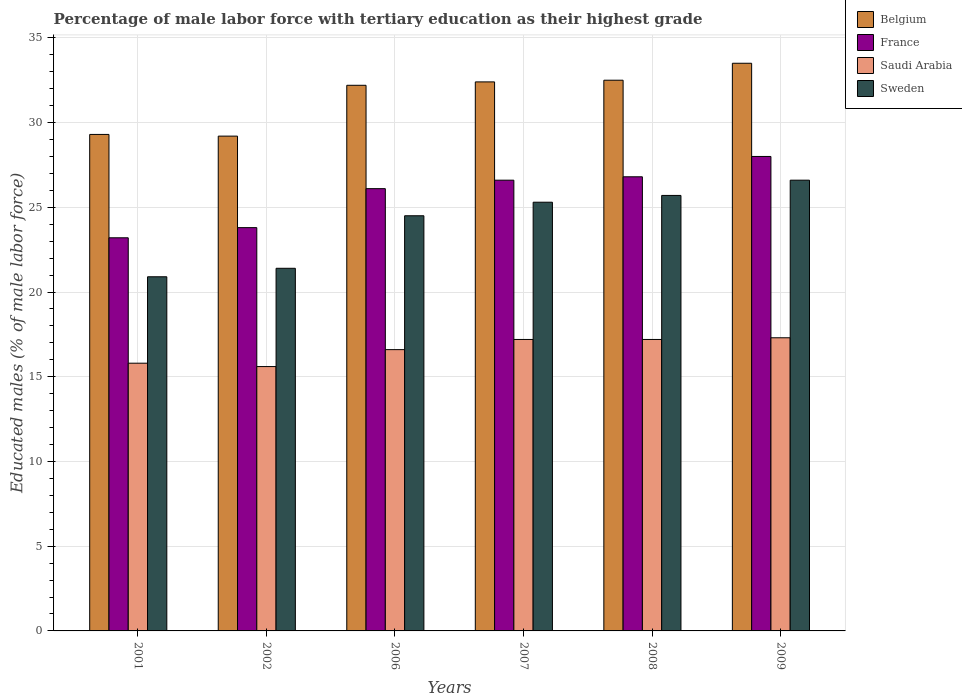How many different coloured bars are there?
Provide a short and direct response. 4. How many groups of bars are there?
Ensure brevity in your answer.  6. Are the number of bars on each tick of the X-axis equal?
Ensure brevity in your answer.  Yes. How many bars are there on the 4th tick from the left?
Make the answer very short. 4. In how many cases, is the number of bars for a given year not equal to the number of legend labels?
Give a very brief answer. 0. What is the percentage of male labor force with tertiary education in Sweden in 2008?
Keep it short and to the point. 25.7. Across all years, what is the maximum percentage of male labor force with tertiary education in Saudi Arabia?
Offer a terse response. 17.3. Across all years, what is the minimum percentage of male labor force with tertiary education in Sweden?
Your answer should be compact. 20.9. In which year was the percentage of male labor force with tertiary education in Sweden maximum?
Your answer should be very brief. 2009. In which year was the percentage of male labor force with tertiary education in Belgium minimum?
Your response must be concise. 2002. What is the total percentage of male labor force with tertiary education in Saudi Arabia in the graph?
Offer a very short reply. 99.7. What is the difference between the percentage of male labor force with tertiary education in Sweden in 2006 and that in 2009?
Make the answer very short. -2.1. What is the difference between the percentage of male labor force with tertiary education in Saudi Arabia in 2007 and the percentage of male labor force with tertiary education in Sweden in 2006?
Make the answer very short. -7.3. What is the average percentage of male labor force with tertiary education in Saudi Arabia per year?
Provide a succinct answer. 16.62. In the year 2009, what is the difference between the percentage of male labor force with tertiary education in France and percentage of male labor force with tertiary education in Sweden?
Offer a very short reply. 1.4. In how many years, is the percentage of male labor force with tertiary education in Saudi Arabia greater than 10 %?
Offer a terse response. 6. Is the percentage of male labor force with tertiary education in Sweden in 2002 less than that in 2008?
Your response must be concise. Yes. Is the difference between the percentage of male labor force with tertiary education in France in 2008 and 2009 greater than the difference between the percentage of male labor force with tertiary education in Sweden in 2008 and 2009?
Keep it short and to the point. No. What is the difference between the highest and the second highest percentage of male labor force with tertiary education in Saudi Arabia?
Provide a short and direct response. 0.1. What is the difference between the highest and the lowest percentage of male labor force with tertiary education in France?
Give a very brief answer. 4.8. What does the 3rd bar from the right in 2008 represents?
Make the answer very short. France. What is the difference between two consecutive major ticks on the Y-axis?
Provide a short and direct response. 5. Are the values on the major ticks of Y-axis written in scientific E-notation?
Make the answer very short. No. How are the legend labels stacked?
Your answer should be compact. Vertical. What is the title of the graph?
Make the answer very short. Percentage of male labor force with tertiary education as their highest grade. Does "Timor-Leste" appear as one of the legend labels in the graph?
Your response must be concise. No. What is the label or title of the X-axis?
Offer a terse response. Years. What is the label or title of the Y-axis?
Offer a terse response. Educated males (% of male labor force). What is the Educated males (% of male labor force) in Belgium in 2001?
Offer a very short reply. 29.3. What is the Educated males (% of male labor force) in France in 2001?
Provide a short and direct response. 23.2. What is the Educated males (% of male labor force) in Saudi Arabia in 2001?
Ensure brevity in your answer.  15.8. What is the Educated males (% of male labor force) of Sweden in 2001?
Offer a terse response. 20.9. What is the Educated males (% of male labor force) of Belgium in 2002?
Give a very brief answer. 29.2. What is the Educated males (% of male labor force) in France in 2002?
Keep it short and to the point. 23.8. What is the Educated males (% of male labor force) in Saudi Arabia in 2002?
Ensure brevity in your answer.  15.6. What is the Educated males (% of male labor force) in Sweden in 2002?
Make the answer very short. 21.4. What is the Educated males (% of male labor force) in Belgium in 2006?
Give a very brief answer. 32.2. What is the Educated males (% of male labor force) of France in 2006?
Ensure brevity in your answer.  26.1. What is the Educated males (% of male labor force) of Saudi Arabia in 2006?
Your response must be concise. 16.6. What is the Educated males (% of male labor force) in Sweden in 2006?
Your answer should be compact. 24.5. What is the Educated males (% of male labor force) of Belgium in 2007?
Offer a terse response. 32.4. What is the Educated males (% of male labor force) in France in 2007?
Your answer should be compact. 26.6. What is the Educated males (% of male labor force) of Saudi Arabia in 2007?
Provide a short and direct response. 17.2. What is the Educated males (% of male labor force) of Sweden in 2007?
Keep it short and to the point. 25.3. What is the Educated males (% of male labor force) of Belgium in 2008?
Ensure brevity in your answer.  32.5. What is the Educated males (% of male labor force) in France in 2008?
Ensure brevity in your answer.  26.8. What is the Educated males (% of male labor force) of Saudi Arabia in 2008?
Provide a short and direct response. 17.2. What is the Educated males (% of male labor force) in Sweden in 2008?
Make the answer very short. 25.7. What is the Educated males (% of male labor force) of Belgium in 2009?
Make the answer very short. 33.5. What is the Educated males (% of male labor force) in France in 2009?
Offer a terse response. 28. What is the Educated males (% of male labor force) in Saudi Arabia in 2009?
Provide a succinct answer. 17.3. What is the Educated males (% of male labor force) in Sweden in 2009?
Your response must be concise. 26.6. Across all years, what is the maximum Educated males (% of male labor force) of Belgium?
Ensure brevity in your answer.  33.5. Across all years, what is the maximum Educated males (% of male labor force) in France?
Provide a succinct answer. 28. Across all years, what is the maximum Educated males (% of male labor force) in Saudi Arabia?
Make the answer very short. 17.3. Across all years, what is the maximum Educated males (% of male labor force) of Sweden?
Provide a succinct answer. 26.6. Across all years, what is the minimum Educated males (% of male labor force) of Belgium?
Keep it short and to the point. 29.2. Across all years, what is the minimum Educated males (% of male labor force) of France?
Your answer should be compact. 23.2. Across all years, what is the minimum Educated males (% of male labor force) of Saudi Arabia?
Keep it short and to the point. 15.6. Across all years, what is the minimum Educated males (% of male labor force) in Sweden?
Keep it short and to the point. 20.9. What is the total Educated males (% of male labor force) in Belgium in the graph?
Offer a terse response. 189.1. What is the total Educated males (% of male labor force) in France in the graph?
Make the answer very short. 154.5. What is the total Educated males (% of male labor force) in Saudi Arabia in the graph?
Give a very brief answer. 99.7. What is the total Educated males (% of male labor force) in Sweden in the graph?
Offer a terse response. 144.4. What is the difference between the Educated males (% of male labor force) of Sweden in 2001 and that in 2002?
Offer a terse response. -0.5. What is the difference between the Educated males (% of male labor force) of Belgium in 2001 and that in 2007?
Ensure brevity in your answer.  -3.1. What is the difference between the Educated males (% of male labor force) in Saudi Arabia in 2001 and that in 2007?
Provide a short and direct response. -1.4. What is the difference between the Educated males (% of male labor force) of Sweden in 2001 and that in 2007?
Provide a succinct answer. -4.4. What is the difference between the Educated males (% of male labor force) of Belgium in 2001 and that in 2008?
Provide a succinct answer. -3.2. What is the difference between the Educated males (% of male labor force) in Sweden in 2001 and that in 2008?
Provide a short and direct response. -4.8. What is the difference between the Educated males (% of male labor force) of Belgium in 2001 and that in 2009?
Provide a short and direct response. -4.2. What is the difference between the Educated males (% of male labor force) in Saudi Arabia in 2001 and that in 2009?
Keep it short and to the point. -1.5. What is the difference between the Educated males (% of male labor force) of Sweden in 2002 and that in 2006?
Ensure brevity in your answer.  -3.1. What is the difference between the Educated males (% of male labor force) of France in 2002 and that in 2007?
Your answer should be very brief. -2.8. What is the difference between the Educated males (% of male labor force) in Belgium in 2002 and that in 2008?
Give a very brief answer. -3.3. What is the difference between the Educated males (% of male labor force) of France in 2002 and that in 2008?
Make the answer very short. -3. What is the difference between the Educated males (% of male labor force) in France in 2002 and that in 2009?
Provide a succinct answer. -4.2. What is the difference between the Educated males (% of male labor force) in Saudi Arabia in 2002 and that in 2009?
Your answer should be compact. -1.7. What is the difference between the Educated males (% of male labor force) in Sweden in 2002 and that in 2009?
Provide a short and direct response. -5.2. What is the difference between the Educated males (% of male labor force) in France in 2006 and that in 2007?
Offer a very short reply. -0.5. What is the difference between the Educated males (% of male labor force) of Saudi Arabia in 2006 and that in 2007?
Your response must be concise. -0.6. What is the difference between the Educated males (% of male labor force) in Sweden in 2006 and that in 2007?
Keep it short and to the point. -0.8. What is the difference between the Educated males (% of male labor force) of Sweden in 2006 and that in 2008?
Provide a short and direct response. -1.2. What is the difference between the Educated males (% of male labor force) of Belgium in 2006 and that in 2009?
Ensure brevity in your answer.  -1.3. What is the difference between the Educated males (% of male labor force) in France in 2006 and that in 2009?
Offer a terse response. -1.9. What is the difference between the Educated males (% of male labor force) of France in 2007 and that in 2008?
Your answer should be compact. -0.2. What is the difference between the Educated males (% of male labor force) of Sweden in 2007 and that in 2008?
Your answer should be very brief. -0.4. What is the difference between the Educated males (% of male labor force) in Belgium in 2008 and that in 2009?
Your answer should be very brief. -1. What is the difference between the Educated males (% of male labor force) in France in 2008 and that in 2009?
Provide a short and direct response. -1.2. What is the difference between the Educated males (% of male labor force) of France in 2001 and the Educated males (% of male labor force) of Saudi Arabia in 2002?
Provide a succinct answer. 7.6. What is the difference between the Educated males (% of male labor force) in France in 2001 and the Educated males (% of male labor force) in Sweden in 2002?
Make the answer very short. 1.8. What is the difference between the Educated males (% of male labor force) of Saudi Arabia in 2001 and the Educated males (% of male labor force) of Sweden in 2002?
Offer a terse response. -5.6. What is the difference between the Educated males (% of male labor force) in Belgium in 2001 and the Educated males (% of male labor force) in Saudi Arabia in 2006?
Ensure brevity in your answer.  12.7. What is the difference between the Educated males (% of male labor force) of France in 2001 and the Educated males (% of male labor force) of Saudi Arabia in 2006?
Your answer should be very brief. 6.6. What is the difference between the Educated males (% of male labor force) of Belgium in 2001 and the Educated males (% of male labor force) of France in 2007?
Keep it short and to the point. 2.7. What is the difference between the Educated males (% of male labor force) of France in 2001 and the Educated males (% of male labor force) of Sweden in 2007?
Your response must be concise. -2.1. What is the difference between the Educated males (% of male labor force) of Saudi Arabia in 2001 and the Educated males (% of male labor force) of Sweden in 2008?
Ensure brevity in your answer.  -9.9. What is the difference between the Educated males (% of male labor force) of Belgium in 2001 and the Educated males (% of male labor force) of France in 2009?
Provide a succinct answer. 1.3. What is the difference between the Educated males (% of male labor force) in Belgium in 2001 and the Educated males (% of male labor force) in Saudi Arabia in 2009?
Your answer should be very brief. 12. What is the difference between the Educated males (% of male labor force) in France in 2001 and the Educated males (% of male labor force) in Sweden in 2009?
Your answer should be compact. -3.4. What is the difference between the Educated males (% of male labor force) of Saudi Arabia in 2001 and the Educated males (% of male labor force) of Sweden in 2009?
Your answer should be very brief. -10.8. What is the difference between the Educated males (% of male labor force) in Belgium in 2002 and the Educated males (% of male labor force) in Saudi Arabia in 2006?
Provide a short and direct response. 12.6. What is the difference between the Educated males (% of male labor force) in Saudi Arabia in 2002 and the Educated males (% of male labor force) in Sweden in 2006?
Your answer should be compact. -8.9. What is the difference between the Educated males (% of male labor force) in France in 2002 and the Educated males (% of male labor force) in Saudi Arabia in 2007?
Your answer should be very brief. 6.6. What is the difference between the Educated males (% of male labor force) in France in 2002 and the Educated males (% of male labor force) in Sweden in 2007?
Give a very brief answer. -1.5. What is the difference between the Educated males (% of male labor force) of Belgium in 2002 and the Educated males (% of male labor force) of France in 2008?
Give a very brief answer. 2.4. What is the difference between the Educated males (% of male labor force) of Belgium in 2002 and the Educated males (% of male labor force) of Saudi Arabia in 2008?
Offer a very short reply. 12. What is the difference between the Educated males (% of male labor force) in Belgium in 2002 and the Educated males (% of male labor force) in Sweden in 2008?
Provide a short and direct response. 3.5. What is the difference between the Educated males (% of male labor force) of France in 2002 and the Educated males (% of male labor force) of Sweden in 2008?
Offer a terse response. -1.9. What is the difference between the Educated males (% of male labor force) in Belgium in 2002 and the Educated males (% of male labor force) in France in 2009?
Offer a very short reply. 1.2. What is the difference between the Educated males (% of male labor force) of Belgium in 2002 and the Educated males (% of male labor force) of Sweden in 2009?
Your answer should be compact. 2.6. What is the difference between the Educated males (% of male labor force) in Belgium in 2006 and the Educated males (% of male labor force) in Saudi Arabia in 2007?
Ensure brevity in your answer.  15. What is the difference between the Educated males (% of male labor force) of Belgium in 2006 and the Educated males (% of male labor force) of Sweden in 2007?
Offer a terse response. 6.9. What is the difference between the Educated males (% of male labor force) of Saudi Arabia in 2006 and the Educated males (% of male labor force) of Sweden in 2007?
Your answer should be compact. -8.7. What is the difference between the Educated males (% of male labor force) of Belgium in 2006 and the Educated males (% of male labor force) of France in 2008?
Make the answer very short. 5.4. What is the difference between the Educated males (% of male labor force) in Belgium in 2006 and the Educated males (% of male labor force) in Saudi Arabia in 2008?
Your answer should be very brief. 15. What is the difference between the Educated males (% of male labor force) in Belgium in 2006 and the Educated males (% of male labor force) in Saudi Arabia in 2009?
Your answer should be compact. 14.9. What is the difference between the Educated males (% of male labor force) in France in 2006 and the Educated males (% of male labor force) in Saudi Arabia in 2009?
Make the answer very short. 8.8. What is the difference between the Educated males (% of male labor force) in Belgium in 2007 and the Educated males (% of male labor force) in France in 2008?
Your response must be concise. 5.6. What is the difference between the Educated males (% of male labor force) in Belgium in 2007 and the Educated males (% of male labor force) in Sweden in 2008?
Ensure brevity in your answer.  6.7. What is the difference between the Educated males (% of male labor force) of Saudi Arabia in 2007 and the Educated males (% of male labor force) of Sweden in 2008?
Make the answer very short. -8.5. What is the difference between the Educated males (% of male labor force) of Belgium in 2007 and the Educated males (% of male labor force) of France in 2009?
Provide a short and direct response. 4.4. What is the difference between the Educated males (% of male labor force) of Belgium in 2007 and the Educated males (% of male labor force) of Saudi Arabia in 2009?
Make the answer very short. 15.1. What is the difference between the Educated males (% of male labor force) of Belgium in 2007 and the Educated males (% of male labor force) of Sweden in 2009?
Offer a very short reply. 5.8. What is the difference between the Educated males (% of male labor force) of France in 2007 and the Educated males (% of male labor force) of Saudi Arabia in 2009?
Ensure brevity in your answer.  9.3. What is the difference between the Educated males (% of male labor force) in Belgium in 2008 and the Educated males (% of male labor force) in France in 2009?
Make the answer very short. 4.5. What is the difference between the Educated males (% of male labor force) of Belgium in 2008 and the Educated males (% of male labor force) of Saudi Arabia in 2009?
Give a very brief answer. 15.2. What is the difference between the Educated males (% of male labor force) of Belgium in 2008 and the Educated males (% of male labor force) of Sweden in 2009?
Your answer should be compact. 5.9. What is the difference between the Educated males (% of male labor force) of France in 2008 and the Educated males (% of male labor force) of Sweden in 2009?
Make the answer very short. 0.2. What is the average Educated males (% of male labor force) of Belgium per year?
Give a very brief answer. 31.52. What is the average Educated males (% of male labor force) in France per year?
Provide a succinct answer. 25.75. What is the average Educated males (% of male labor force) of Saudi Arabia per year?
Make the answer very short. 16.62. What is the average Educated males (% of male labor force) in Sweden per year?
Offer a terse response. 24.07. In the year 2001, what is the difference between the Educated males (% of male labor force) of Belgium and Educated males (% of male labor force) of Saudi Arabia?
Provide a short and direct response. 13.5. In the year 2001, what is the difference between the Educated males (% of male labor force) in Belgium and Educated males (% of male labor force) in Sweden?
Offer a terse response. 8.4. In the year 2001, what is the difference between the Educated males (% of male labor force) of France and Educated males (% of male labor force) of Saudi Arabia?
Give a very brief answer. 7.4. In the year 2001, what is the difference between the Educated males (% of male labor force) in France and Educated males (% of male labor force) in Sweden?
Give a very brief answer. 2.3. In the year 2002, what is the difference between the Educated males (% of male labor force) in Belgium and Educated males (% of male labor force) in France?
Keep it short and to the point. 5.4. In the year 2002, what is the difference between the Educated males (% of male labor force) of Belgium and Educated males (% of male labor force) of Saudi Arabia?
Your response must be concise. 13.6. In the year 2006, what is the difference between the Educated males (% of male labor force) of Belgium and Educated males (% of male labor force) of Saudi Arabia?
Your response must be concise. 15.6. In the year 2006, what is the difference between the Educated males (% of male labor force) of Belgium and Educated males (% of male labor force) of Sweden?
Your answer should be very brief. 7.7. In the year 2006, what is the difference between the Educated males (% of male labor force) in France and Educated males (% of male labor force) in Saudi Arabia?
Make the answer very short. 9.5. In the year 2006, what is the difference between the Educated males (% of male labor force) of France and Educated males (% of male labor force) of Sweden?
Provide a succinct answer. 1.6. In the year 2006, what is the difference between the Educated males (% of male labor force) in Saudi Arabia and Educated males (% of male labor force) in Sweden?
Offer a very short reply. -7.9. In the year 2007, what is the difference between the Educated males (% of male labor force) in Belgium and Educated males (% of male labor force) in France?
Provide a succinct answer. 5.8. In the year 2007, what is the difference between the Educated males (% of male labor force) of Saudi Arabia and Educated males (% of male labor force) of Sweden?
Give a very brief answer. -8.1. In the year 2008, what is the difference between the Educated males (% of male labor force) in Belgium and Educated males (% of male labor force) in France?
Provide a succinct answer. 5.7. In the year 2008, what is the difference between the Educated males (% of male labor force) in Belgium and Educated males (% of male labor force) in Saudi Arabia?
Offer a terse response. 15.3. In the year 2008, what is the difference between the Educated males (% of male labor force) in France and Educated males (% of male labor force) in Saudi Arabia?
Make the answer very short. 9.6. In the year 2008, what is the difference between the Educated males (% of male labor force) of France and Educated males (% of male labor force) of Sweden?
Give a very brief answer. 1.1. In the year 2008, what is the difference between the Educated males (% of male labor force) in Saudi Arabia and Educated males (% of male labor force) in Sweden?
Give a very brief answer. -8.5. In the year 2009, what is the difference between the Educated males (% of male labor force) in Belgium and Educated males (% of male labor force) in Saudi Arabia?
Offer a terse response. 16.2. In the year 2009, what is the difference between the Educated males (% of male labor force) in France and Educated males (% of male labor force) in Saudi Arabia?
Your answer should be compact. 10.7. What is the ratio of the Educated males (% of male labor force) of France in 2001 to that in 2002?
Your response must be concise. 0.97. What is the ratio of the Educated males (% of male labor force) in Saudi Arabia in 2001 to that in 2002?
Ensure brevity in your answer.  1.01. What is the ratio of the Educated males (% of male labor force) in Sweden in 2001 to that in 2002?
Offer a very short reply. 0.98. What is the ratio of the Educated males (% of male labor force) of Belgium in 2001 to that in 2006?
Ensure brevity in your answer.  0.91. What is the ratio of the Educated males (% of male labor force) in France in 2001 to that in 2006?
Offer a very short reply. 0.89. What is the ratio of the Educated males (% of male labor force) of Saudi Arabia in 2001 to that in 2006?
Make the answer very short. 0.95. What is the ratio of the Educated males (% of male labor force) of Sweden in 2001 to that in 2006?
Offer a very short reply. 0.85. What is the ratio of the Educated males (% of male labor force) in Belgium in 2001 to that in 2007?
Offer a terse response. 0.9. What is the ratio of the Educated males (% of male labor force) in France in 2001 to that in 2007?
Give a very brief answer. 0.87. What is the ratio of the Educated males (% of male labor force) of Saudi Arabia in 2001 to that in 2007?
Offer a very short reply. 0.92. What is the ratio of the Educated males (% of male labor force) of Sweden in 2001 to that in 2007?
Your response must be concise. 0.83. What is the ratio of the Educated males (% of male labor force) in Belgium in 2001 to that in 2008?
Your response must be concise. 0.9. What is the ratio of the Educated males (% of male labor force) of France in 2001 to that in 2008?
Provide a succinct answer. 0.87. What is the ratio of the Educated males (% of male labor force) of Saudi Arabia in 2001 to that in 2008?
Ensure brevity in your answer.  0.92. What is the ratio of the Educated males (% of male labor force) in Sweden in 2001 to that in 2008?
Provide a succinct answer. 0.81. What is the ratio of the Educated males (% of male labor force) in Belgium in 2001 to that in 2009?
Make the answer very short. 0.87. What is the ratio of the Educated males (% of male labor force) of France in 2001 to that in 2009?
Ensure brevity in your answer.  0.83. What is the ratio of the Educated males (% of male labor force) of Saudi Arabia in 2001 to that in 2009?
Give a very brief answer. 0.91. What is the ratio of the Educated males (% of male labor force) in Sweden in 2001 to that in 2009?
Offer a very short reply. 0.79. What is the ratio of the Educated males (% of male labor force) of Belgium in 2002 to that in 2006?
Your answer should be very brief. 0.91. What is the ratio of the Educated males (% of male labor force) in France in 2002 to that in 2006?
Offer a terse response. 0.91. What is the ratio of the Educated males (% of male labor force) of Saudi Arabia in 2002 to that in 2006?
Your response must be concise. 0.94. What is the ratio of the Educated males (% of male labor force) in Sweden in 2002 to that in 2006?
Provide a succinct answer. 0.87. What is the ratio of the Educated males (% of male labor force) of Belgium in 2002 to that in 2007?
Offer a very short reply. 0.9. What is the ratio of the Educated males (% of male labor force) in France in 2002 to that in 2007?
Give a very brief answer. 0.89. What is the ratio of the Educated males (% of male labor force) in Saudi Arabia in 2002 to that in 2007?
Provide a short and direct response. 0.91. What is the ratio of the Educated males (% of male labor force) in Sweden in 2002 to that in 2007?
Offer a very short reply. 0.85. What is the ratio of the Educated males (% of male labor force) of Belgium in 2002 to that in 2008?
Offer a terse response. 0.9. What is the ratio of the Educated males (% of male labor force) of France in 2002 to that in 2008?
Ensure brevity in your answer.  0.89. What is the ratio of the Educated males (% of male labor force) of Saudi Arabia in 2002 to that in 2008?
Provide a succinct answer. 0.91. What is the ratio of the Educated males (% of male labor force) of Sweden in 2002 to that in 2008?
Ensure brevity in your answer.  0.83. What is the ratio of the Educated males (% of male labor force) in Belgium in 2002 to that in 2009?
Your answer should be very brief. 0.87. What is the ratio of the Educated males (% of male labor force) in France in 2002 to that in 2009?
Offer a terse response. 0.85. What is the ratio of the Educated males (% of male labor force) of Saudi Arabia in 2002 to that in 2009?
Ensure brevity in your answer.  0.9. What is the ratio of the Educated males (% of male labor force) in Sweden in 2002 to that in 2009?
Give a very brief answer. 0.8. What is the ratio of the Educated males (% of male labor force) of France in 2006 to that in 2007?
Offer a terse response. 0.98. What is the ratio of the Educated males (% of male labor force) of Saudi Arabia in 2006 to that in 2007?
Keep it short and to the point. 0.97. What is the ratio of the Educated males (% of male labor force) in Sweden in 2006 to that in 2007?
Offer a terse response. 0.97. What is the ratio of the Educated males (% of male labor force) in France in 2006 to that in 2008?
Offer a very short reply. 0.97. What is the ratio of the Educated males (% of male labor force) of Saudi Arabia in 2006 to that in 2008?
Offer a terse response. 0.97. What is the ratio of the Educated males (% of male labor force) in Sweden in 2006 to that in 2008?
Your answer should be very brief. 0.95. What is the ratio of the Educated males (% of male labor force) of Belgium in 2006 to that in 2009?
Your answer should be very brief. 0.96. What is the ratio of the Educated males (% of male labor force) of France in 2006 to that in 2009?
Offer a very short reply. 0.93. What is the ratio of the Educated males (% of male labor force) of Saudi Arabia in 2006 to that in 2009?
Offer a terse response. 0.96. What is the ratio of the Educated males (% of male labor force) of Sweden in 2006 to that in 2009?
Ensure brevity in your answer.  0.92. What is the ratio of the Educated males (% of male labor force) in Belgium in 2007 to that in 2008?
Provide a succinct answer. 1. What is the ratio of the Educated males (% of male labor force) in France in 2007 to that in 2008?
Provide a short and direct response. 0.99. What is the ratio of the Educated males (% of male labor force) of Saudi Arabia in 2007 to that in 2008?
Keep it short and to the point. 1. What is the ratio of the Educated males (% of male labor force) in Sweden in 2007 to that in 2008?
Offer a terse response. 0.98. What is the ratio of the Educated males (% of male labor force) in Belgium in 2007 to that in 2009?
Give a very brief answer. 0.97. What is the ratio of the Educated males (% of male labor force) in France in 2007 to that in 2009?
Offer a very short reply. 0.95. What is the ratio of the Educated males (% of male labor force) in Sweden in 2007 to that in 2009?
Your response must be concise. 0.95. What is the ratio of the Educated males (% of male labor force) of Belgium in 2008 to that in 2009?
Offer a very short reply. 0.97. What is the ratio of the Educated males (% of male labor force) in France in 2008 to that in 2009?
Give a very brief answer. 0.96. What is the ratio of the Educated males (% of male labor force) in Sweden in 2008 to that in 2009?
Keep it short and to the point. 0.97. What is the difference between the highest and the second highest Educated males (% of male labor force) of Belgium?
Ensure brevity in your answer.  1. What is the difference between the highest and the second highest Educated males (% of male labor force) of Saudi Arabia?
Your answer should be compact. 0.1. What is the difference between the highest and the lowest Educated males (% of male labor force) of Belgium?
Offer a very short reply. 4.3. What is the difference between the highest and the lowest Educated males (% of male labor force) in France?
Ensure brevity in your answer.  4.8. What is the difference between the highest and the lowest Educated males (% of male labor force) in Saudi Arabia?
Provide a short and direct response. 1.7. 